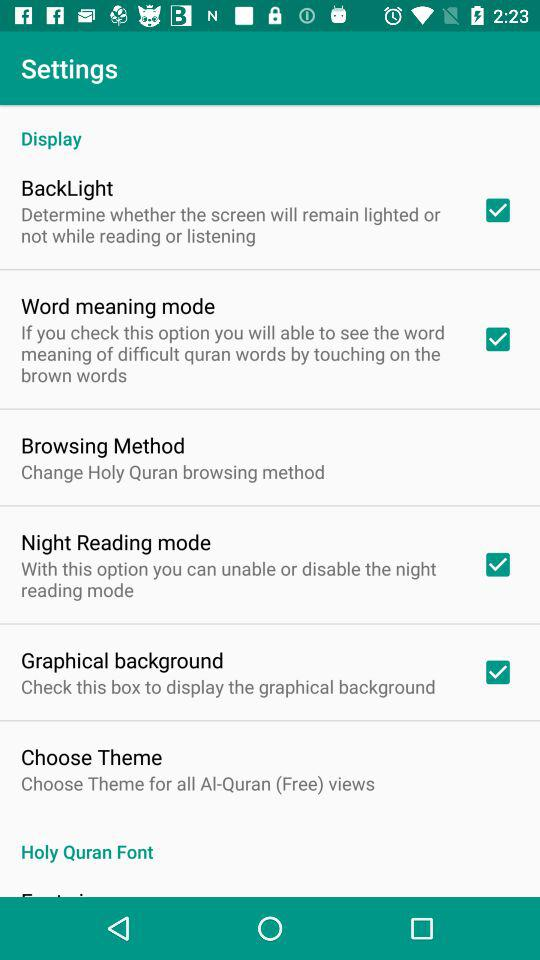How many checkboxes are in this settings screen?
Answer the question using a single word or phrase. 4 